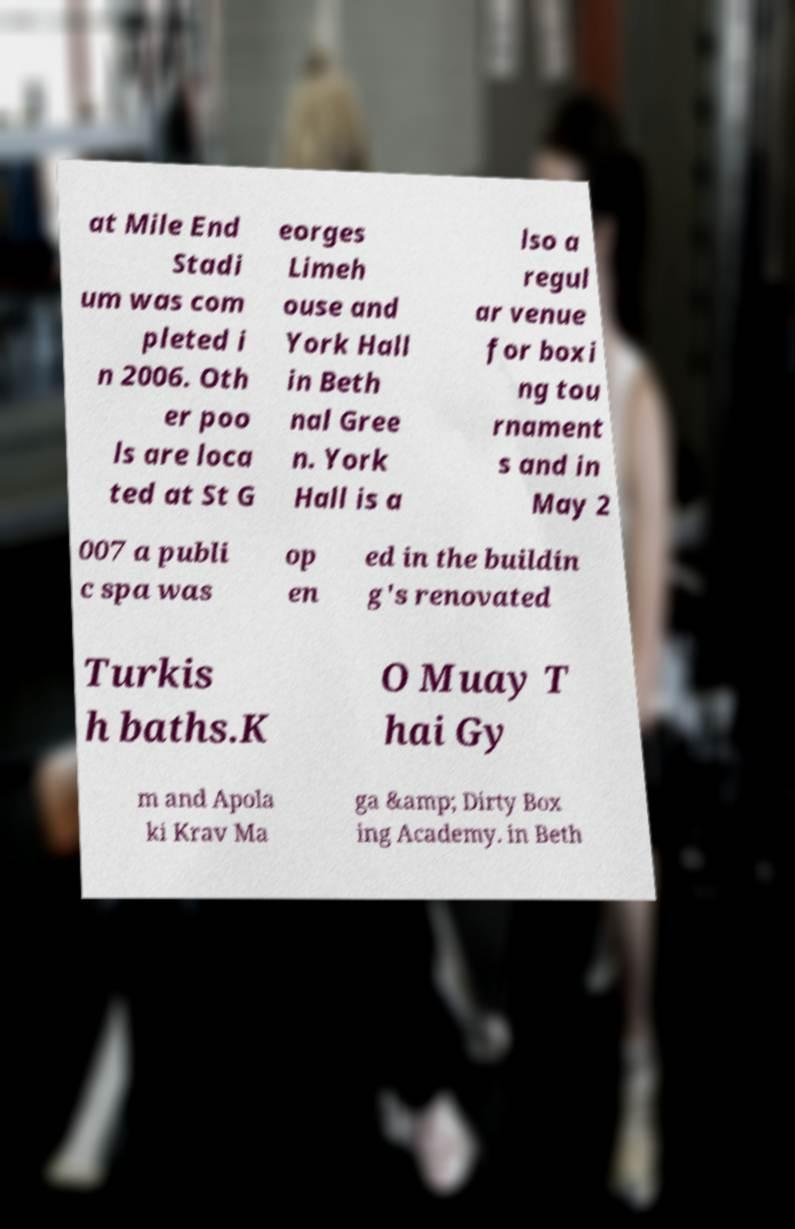Can you read and provide the text displayed in the image?This photo seems to have some interesting text. Can you extract and type it out for me? at Mile End Stadi um was com pleted i n 2006. Oth er poo ls are loca ted at St G eorges Limeh ouse and York Hall in Beth nal Gree n. York Hall is a lso a regul ar venue for boxi ng tou rnament s and in May 2 007 a publi c spa was op en ed in the buildin g's renovated Turkis h baths.K O Muay T hai Gy m and Apola ki Krav Ma ga &amp; Dirty Box ing Academy. in Beth 